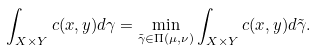<formula> <loc_0><loc_0><loc_500><loc_500>\int _ { X \times Y } c ( x , y ) d \gamma = \min _ { \tilde { \gamma } \in \Pi ( \mu , \nu ) } \int _ { X \times Y } c ( x , y ) d \tilde { \gamma } .</formula> 